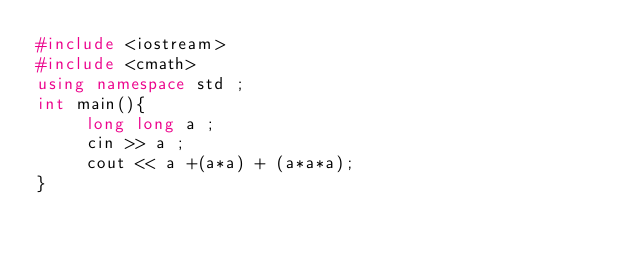Convert code to text. <code><loc_0><loc_0><loc_500><loc_500><_C++_>#include <iostream>
#include <cmath>
using namespace std ;
int main(){
     long long a ;
     cin >> a ;
     cout << a +(a*a) + (a*a*a);
}
</code> 